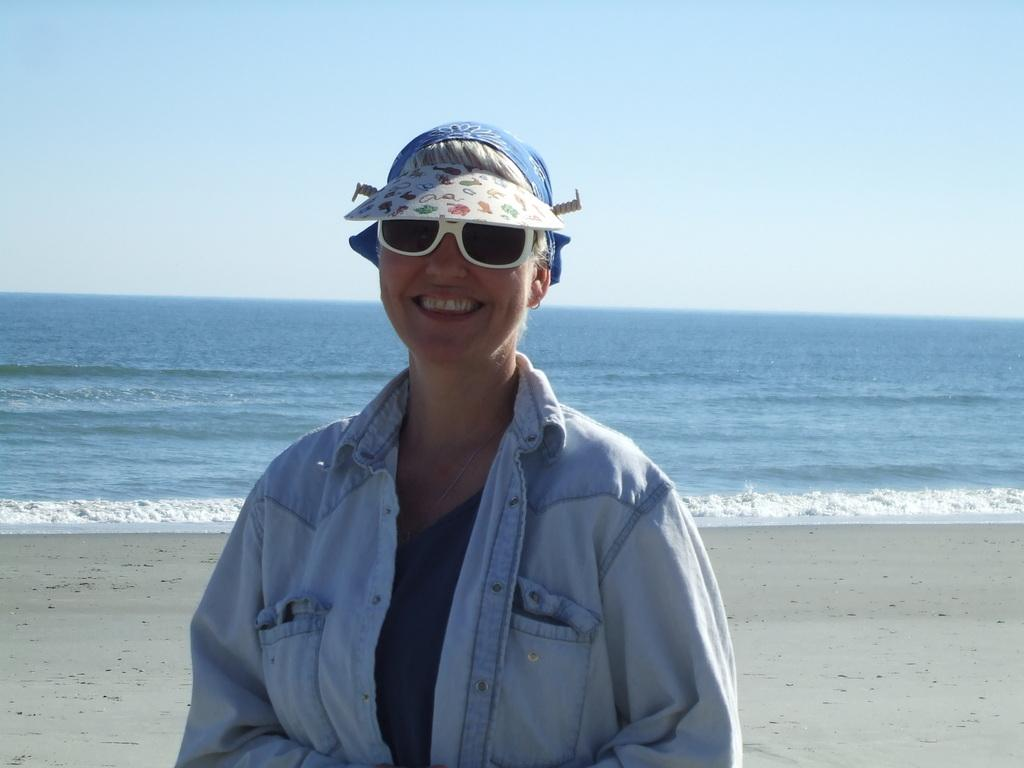Who is the main subject in the image? There is a lady in the center of the image. What is the lady doing in the image? The lady is standing and smiling. What is the lady wearing in the image? The lady is wearing a jacket. What can be seen in the background of the image? There is a sea and sky visible in the background of the image. What type of insurance does the lady have for her patch in the image? There is no mention of a patch or insurance in the image; the lady is simply standing and smiling. 